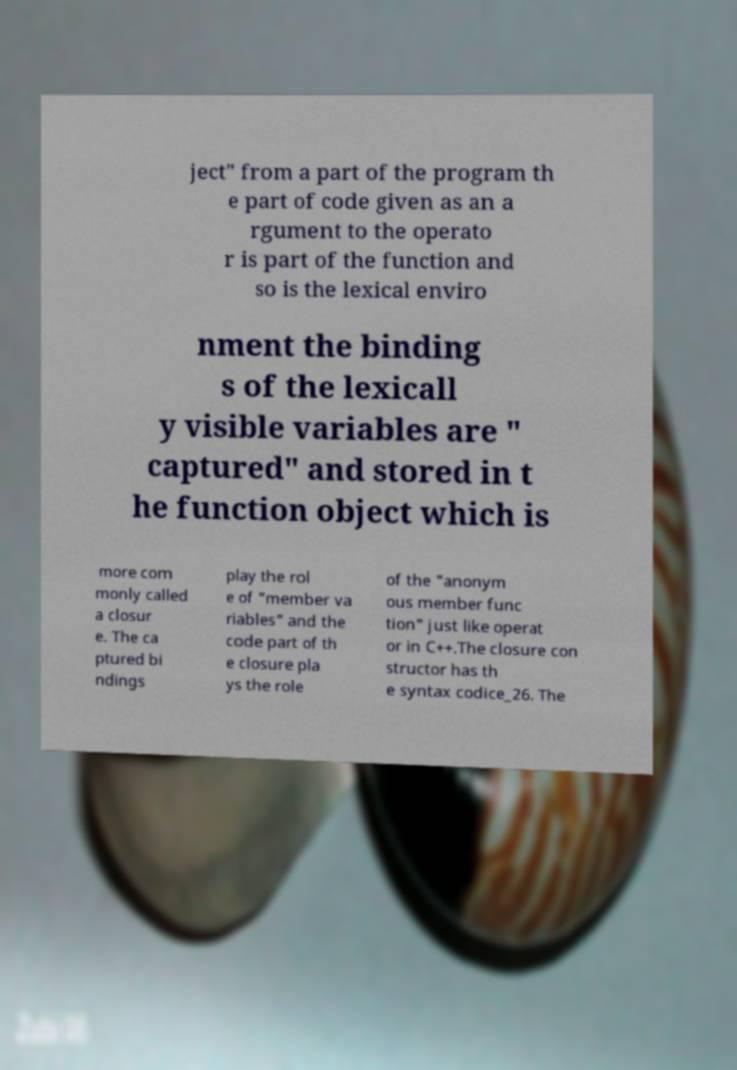I need the written content from this picture converted into text. Can you do that? ject" from a part of the program th e part of code given as an a rgument to the operato r is part of the function and so is the lexical enviro nment the binding s of the lexicall y visible variables are " captured" and stored in t he function object which is more com monly called a closur e. The ca ptured bi ndings play the rol e of "member va riables" and the code part of th e closure pla ys the role of the "anonym ous member func tion" just like operat or in C++.The closure con structor has th e syntax codice_26. The 